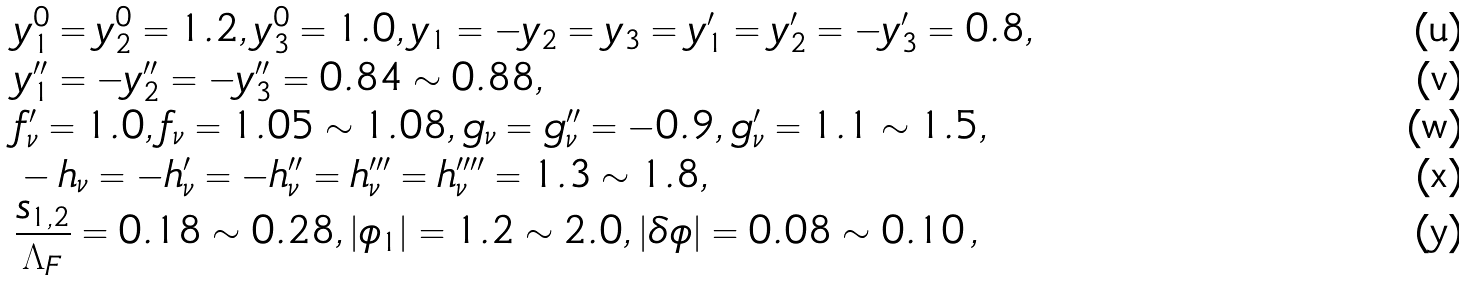Convert formula to latex. <formula><loc_0><loc_0><loc_500><loc_500>& y ^ { 0 } _ { 1 } = y ^ { 0 } _ { 2 } = 1 . 2 , y ^ { 0 } _ { 3 } = 1 . 0 , y _ { 1 } = - y _ { 2 } = y _ { 3 } = y _ { 1 } ^ { \prime } = y _ { 2 } ^ { \prime } = - y _ { 3 } ^ { \prime } = 0 . 8 , \\ & y _ { 1 } ^ { \prime \prime } = - y _ { 2 } ^ { \prime \prime } = - y _ { 3 } ^ { \prime \prime } = 0 . 8 4 \sim 0 . 8 8 , \\ & f _ { \nu } ^ { \prime } = 1 . 0 , f _ { \nu } = 1 . 0 5 \sim 1 . 0 8 , g _ { \nu } = g _ { \nu } ^ { \prime \prime } = - 0 . 9 , g _ { \nu } ^ { \prime } = 1 . 1 \sim 1 . 5 , \\ & - h _ { \nu } = - h _ { \nu } ^ { \prime } = - h _ { \nu } ^ { \prime \prime } = h _ { \nu } ^ { \prime \prime \prime } = h _ { \nu } ^ { \prime \prime \prime \prime } = 1 . 3 \sim 1 . 8 , \\ & \frac { s _ { 1 , 2 } } { \Lambda _ { F } } = 0 . 1 8 \sim 0 . 2 8 , | \phi _ { 1 } | = 1 . 2 \sim 2 . 0 , | \delta \phi | = 0 . 0 8 \sim 0 . 1 0 \, ,</formula> 